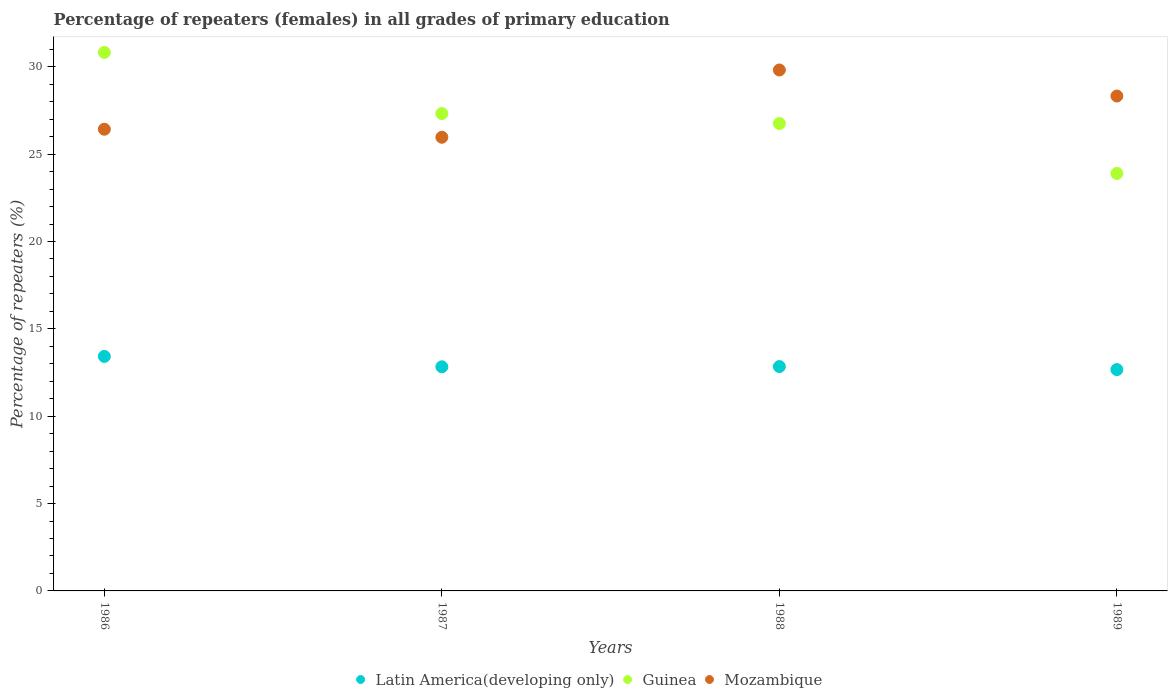How many different coloured dotlines are there?
Give a very brief answer. 3. Is the number of dotlines equal to the number of legend labels?
Ensure brevity in your answer.  Yes. What is the percentage of repeaters (females) in Latin America(developing only) in 1988?
Provide a succinct answer. 12.84. Across all years, what is the maximum percentage of repeaters (females) in Mozambique?
Your response must be concise. 29.82. Across all years, what is the minimum percentage of repeaters (females) in Latin America(developing only)?
Your answer should be compact. 12.67. What is the total percentage of repeaters (females) in Guinea in the graph?
Provide a succinct answer. 108.79. What is the difference between the percentage of repeaters (females) in Latin America(developing only) in 1986 and that in 1987?
Give a very brief answer. 0.59. What is the difference between the percentage of repeaters (females) in Latin America(developing only) in 1986 and the percentage of repeaters (females) in Guinea in 1987?
Provide a short and direct response. -13.9. What is the average percentage of repeaters (females) in Latin America(developing only) per year?
Ensure brevity in your answer.  12.94. In the year 1986, what is the difference between the percentage of repeaters (females) in Mozambique and percentage of repeaters (females) in Latin America(developing only)?
Provide a succinct answer. 13. What is the ratio of the percentage of repeaters (females) in Mozambique in 1987 to that in 1988?
Ensure brevity in your answer.  0.87. What is the difference between the highest and the second highest percentage of repeaters (females) in Mozambique?
Offer a very short reply. 1.49. What is the difference between the highest and the lowest percentage of repeaters (females) in Guinea?
Make the answer very short. 6.92. In how many years, is the percentage of repeaters (females) in Guinea greater than the average percentage of repeaters (females) in Guinea taken over all years?
Offer a very short reply. 2. Does the percentage of repeaters (females) in Guinea monotonically increase over the years?
Provide a short and direct response. No. Is the percentage of repeaters (females) in Mozambique strictly greater than the percentage of repeaters (females) in Latin America(developing only) over the years?
Your answer should be very brief. Yes. Is the percentage of repeaters (females) in Mozambique strictly less than the percentage of repeaters (females) in Guinea over the years?
Keep it short and to the point. No. How many years are there in the graph?
Provide a succinct answer. 4. What is the difference between two consecutive major ticks on the Y-axis?
Provide a succinct answer. 5. How are the legend labels stacked?
Your response must be concise. Horizontal. What is the title of the graph?
Make the answer very short. Percentage of repeaters (females) in all grades of primary education. What is the label or title of the Y-axis?
Provide a succinct answer. Percentage of repeaters (%). What is the Percentage of repeaters (%) of Latin America(developing only) in 1986?
Ensure brevity in your answer.  13.42. What is the Percentage of repeaters (%) in Guinea in 1986?
Offer a terse response. 30.82. What is the Percentage of repeaters (%) of Mozambique in 1986?
Offer a terse response. 26.43. What is the Percentage of repeaters (%) in Latin America(developing only) in 1987?
Keep it short and to the point. 12.83. What is the Percentage of repeaters (%) in Guinea in 1987?
Provide a succinct answer. 27.32. What is the Percentage of repeaters (%) of Mozambique in 1987?
Make the answer very short. 25.97. What is the Percentage of repeaters (%) in Latin America(developing only) in 1988?
Ensure brevity in your answer.  12.84. What is the Percentage of repeaters (%) in Guinea in 1988?
Make the answer very short. 26.75. What is the Percentage of repeaters (%) in Mozambique in 1988?
Provide a succinct answer. 29.82. What is the Percentage of repeaters (%) in Latin America(developing only) in 1989?
Provide a short and direct response. 12.67. What is the Percentage of repeaters (%) in Guinea in 1989?
Provide a short and direct response. 23.9. What is the Percentage of repeaters (%) in Mozambique in 1989?
Your answer should be very brief. 28.33. Across all years, what is the maximum Percentage of repeaters (%) of Latin America(developing only)?
Your answer should be very brief. 13.42. Across all years, what is the maximum Percentage of repeaters (%) of Guinea?
Your answer should be very brief. 30.82. Across all years, what is the maximum Percentage of repeaters (%) of Mozambique?
Provide a short and direct response. 29.82. Across all years, what is the minimum Percentage of repeaters (%) of Latin America(developing only)?
Your answer should be compact. 12.67. Across all years, what is the minimum Percentage of repeaters (%) in Guinea?
Make the answer very short. 23.9. Across all years, what is the minimum Percentage of repeaters (%) of Mozambique?
Your response must be concise. 25.97. What is the total Percentage of repeaters (%) in Latin America(developing only) in the graph?
Provide a short and direct response. 51.76. What is the total Percentage of repeaters (%) in Guinea in the graph?
Keep it short and to the point. 108.79. What is the total Percentage of repeaters (%) of Mozambique in the graph?
Give a very brief answer. 110.53. What is the difference between the Percentage of repeaters (%) of Latin America(developing only) in 1986 and that in 1987?
Give a very brief answer. 0.59. What is the difference between the Percentage of repeaters (%) in Guinea in 1986 and that in 1987?
Keep it short and to the point. 3.5. What is the difference between the Percentage of repeaters (%) in Mozambique in 1986 and that in 1987?
Your answer should be very brief. 0.46. What is the difference between the Percentage of repeaters (%) in Latin America(developing only) in 1986 and that in 1988?
Ensure brevity in your answer.  0.58. What is the difference between the Percentage of repeaters (%) in Guinea in 1986 and that in 1988?
Make the answer very short. 4.07. What is the difference between the Percentage of repeaters (%) in Mozambique in 1986 and that in 1988?
Provide a short and direct response. -3.39. What is the difference between the Percentage of repeaters (%) in Latin America(developing only) in 1986 and that in 1989?
Your answer should be very brief. 0.75. What is the difference between the Percentage of repeaters (%) in Guinea in 1986 and that in 1989?
Your response must be concise. 6.92. What is the difference between the Percentage of repeaters (%) of Mozambique in 1986 and that in 1989?
Your answer should be very brief. -1.9. What is the difference between the Percentage of repeaters (%) in Latin America(developing only) in 1987 and that in 1988?
Your response must be concise. -0.01. What is the difference between the Percentage of repeaters (%) in Guinea in 1987 and that in 1988?
Keep it short and to the point. 0.57. What is the difference between the Percentage of repeaters (%) in Mozambique in 1987 and that in 1988?
Ensure brevity in your answer.  -3.85. What is the difference between the Percentage of repeaters (%) of Latin America(developing only) in 1987 and that in 1989?
Keep it short and to the point. 0.16. What is the difference between the Percentage of repeaters (%) of Guinea in 1987 and that in 1989?
Ensure brevity in your answer.  3.43. What is the difference between the Percentage of repeaters (%) in Mozambique in 1987 and that in 1989?
Keep it short and to the point. -2.36. What is the difference between the Percentage of repeaters (%) in Latin America(developing only) in 1988 and that in 1989?
Provide a succinct answer. 0.17. What is the difference between the Percentage of repeaters (%) in Guinea in 1988 and that in 1989?
Offer a terse response. 2.86. What is the difference between the Percentage of repeaters (%) of Mozambique in 1988 and that in 1989?
Provide a short and direct response. 1.49. What is the difference between the Percentage of repeaters (%) of Latin America(developing only) in 1986 and the Percentage of repeaters (%) of Guinea in 1987?
Provide a succinct answer. -13.9. What is the difference between the Percentage of repeaters (%) in Latin America(developing only) in 1986 and the Percentage of repeaters (%) in Mozambique in 1987?
Your response must be concise. -12.54. What is the difference between the Percentage of repeaters (%) in Guinea in 1986 and the Percentage of repeaters (%) in Mozambique in 1987?
Keep it short and to the point. 4.85. What is the difference between the Percentage of repeaters (%) of Latin America(developing only) in 1986 and the Percentage of repeaters (%) of Guinea in 1988?
Give a very brief answer. -13.33. What is the difference between the Percentage of repeaters (%) of Latin America(developing only) in 1986 and the Percentage of repeaters (%) of Mozambique in 1988?
Provide a short and direct response. -16.39. What is the difference between the Percentage of repeaters (%) of Guinea in 1986 and the Percentage of repeaters (%) of Mozambique in 1988?
Make the answer very short. 1. What is the difference between the Percentage of repeaters (%) of Latin America(developing only) in 1986 and the Percentage of repeaters (%) of Guinea in 1989?
Ensure brevity in your answer.  -10.47. What is the difference between the Percentage of repeaters (%) of Latin America(developing only) in 1986 and the Percentage of repeaters (%) of Mozambique in 1989?
Offer a very short reply. -14.9. What is the difference between the Percentage of repeaters (%) in Guinea in 1986 and the Percentage of repeaters (%) in Mozambique in 1989?
Offer a very short reply. 2.49. What is the difference between the Percentage of repeaters (%) of Latin America(developing only) in 1987 and the Percentage of repeaters (%) of Guinea in 1988?
Make the answer very short. -13.92. What is the difference between the Percentage of repeaters (%) in Latin America(developing only) in 1987 and the Percentage of repeaters (%) in Mozambique in 1988?
Offer a terse response. -16.99. What is the difference between the Percentage of repeaters (%) of Guinea in 1987 and the Percentage of repeaters (%) of Mozambique in 1988?
Your response must be concise. -2.49. What is the difference between the Percentage of repeaters (%) in Latin America(developing only) in 1987 and the Percentage of repeaters (%) in Guinea in 1989?
Make the answer very short. -11.07. What is the difference between the Percentage of repeaters (%) in Latin America(developing only) in 1987 and the Percentage of repeaters (%) in Mozambique in 1989?
Offer a terse response. -15.5. What is the difference between the Percentage of repeaters (%) in Guinea in 1987 and the Percentage of repeaters (%) in Mozambique in 1989?
Make the answer very short. -1. What is the difference between the Percentage of repeaters (%) of Latin America(developing only) in 1988 and the Percentage of repeaters (%) of Guinea in 1989?
Offer a terse response. -11.05. What is the difference between the Percentage of repeaters (%) in Latin America(developing only) in 1988 and the Percentage of repeaters (%) in Mozambique in 1989?
Give a very brief answer. -15.48. What is the difference between the Percentage of repeaters (%) of Guinea in 1988 and the Percentage of repeaters (%) of Mozambique in 1989?
Your answer should be very brief. -1.57. What is the average Percentage of repeaters (%) of Latin America(developing only) per year?
Make the answer very short. 12.94. What is the average Percentage of repeaters (%) in Guinea per year?
Provide a short and direct response. 27.2. What is the average Percentage of repeaters (%) in Mozambique per year?
Your response must be concise. 27.63. In the year 1986, what is the difference between the Percentage of repeaters (%) in Latin America(developing only) and Percentage of repeaters (%) in Guinea?
Your response must be concise. -17.4. In the year 1986, what is the difference between the Percentage of repeaters (%) in Latin America(developing only) and Percentage of repeaters (%) in Mozambique?
Your answer should be very brief. -13. In the year 1986, what is the difference between the Percentage of repeaters (%) of Guinea and Percentage of repeaters (%) of Mozambique?
Offer a very short reply. 4.4. In the year 1987, what is the difference between the Percentage of repeaters (%) in Latin America(developing only) and Percentage of repeaters (%) in Guinea?
Provide a short and direct response. -14.49. In the year 1987, what is the difference between the Percentage of repeaters (%) of Latin America(developing only) and Percentage of repeaters (%) of Mozambique?
Make the answer very short. -13.14. In the year 1987, what is the difference between the Percentage of repeaters (%) in Guinea and Percentage of repeaters (%) in Mozambique?
Provide a short and direct response. 1.36. In the year 1988, what is the difference between the Percentage of repeaters (%) in Latin America(developing only) and Percentage of repeaters (%) in Guinea?
Make the answer very short. -13.91. In the year 1988, what is the difference between the Percentage of repeaters (%) in Latin America(developing only) and Percentage of repeaters (%) in Mozambique?
Make the answer very short. -16.97. In the year 1988, what is the difference between the Percentage of repeaters (%) of Guinea and Percentage of repeaters (%) of Mozambique?
Make the answer very short. -3.06. In the year 1989, what is the difference between the Percentage of repeaters (%) in Latin America(developing only) and Percentage of repeaters (%) in Guinea?
Provide a succinct answer. -11.23. In the year 1989, what is the difference between the Percentage of repeaters (%) in Latin America(developing only) and Percentage of repeaters (%) in Mozambique?
Provide a short and direct response. -15.66. In the year 1989, what is the difference between the Percentage of repeaters (%) in Guinea and Percentage of repeaters (%) in Mozambique?
Offer a very short reply. -4.43. What is the ratio of the Percentage of repeaters (%) of Latin America(developing only) in 1986 to that in 1987?
Offer a terse response. 1.05. What is the ratio of the Percentage of repeaters (%) in Guinea in 1986 to that in 1987?
Provide a succinct answer. 1.13. What is the ratio of the Percentage of repeaters (%) in Mozambique in 1986 to that in 1987?
Offer a terse response. 1.02. What is the ratio of the Percentage of repeaters (%) in Latin America(developing only) in 1986 to that in 1988?
Ensure brevity in your answer.  1.05. What is the ratio of the Percentage of repeaters (%) in Guinea in 1986 to that in 1988?
Keep it short and to the point. 1.15. What is the ratio of the Percentage of repeaters (%) in Mozambique in 1986 to that in 1988?
Your answer should be very brief. 0.89. What is the ratio of the Percentage of repeaters (%) of Latin America(developing only) in 1986 to that in 1989?
Ensure brevity in your answer.  1.06. What is the ratio of the Percentage of repeaters (%) in Guinea in 1986 to that in 1989?
Keep it short and to the point. 1.29. What is the ratio of the Percentage of repeaters (%) of Mozambique in 1986 to that in 1989?
Your answer should be very brief. 0.93. What is the ratio of the Percentage of repeaters (%) of Guinea in 1987 to that in 1988?
Make the answer very short. 1.02. What is the ratio of the Percentage of repeaters (%) of Mozambique in 1987 to that in 1988?
Provide a succinct answer. 0.87. What is the ratio of the Percentage of repeaters (%) of Latin America(developing only) in 1987 to that in 1989?
Provide a succinct answer. 1.01. What is the ratio of the Percentage of repeaters (%) in Guinea in 1987 to that in 1989?
Your answer should be very brief. 1.14. What is the ratio of the Percentage of repeaters (%) in Mozambique in 1987 to that in 1989?
Provide a short and direct response. 0.92. What is the ratio of the Percentage of repeaters (%) in Latin America(developing only) in 1988 to that in 1989?
Offer a very short reply. 1.01. What is the ratio of the Percentage of repeaters (%) in Guinea in 1988 to that in 1989?
Give a very brief answer. 1.12. What is the ratio of the Percentage of repeaters (%) of Mozambique in 1988 to that in 1989?
Give a very brief answer. 1.05. What is the difference between the highest and the second highest Percentage of repeaters (%) of Latin America(developing only)?
Offer a very short reply. 0.58. What is the difference between the highest and the second highest Percentage of repeaters (%) in Guinea?
Your answer should be very brief. 3.5. What is the difference between the highest and the second highest Percentage of repeaters (%) in Mozambique?
Provide a short and direct response. 1.49. What is the difference between the highest and the lowest Percentage of repeaters (%) of Latin America(developing only)?
Keep it short and to the point. 0.75. What is the difference between the highest and the lowest Percentage of repeaters (%) of Guinea?
Provide a short and direct response. 6.92. What is the difference between the highest and the lowest Percentage of repeaters (%) in Mozambique?
Provide a short and direct response. 3.85. 